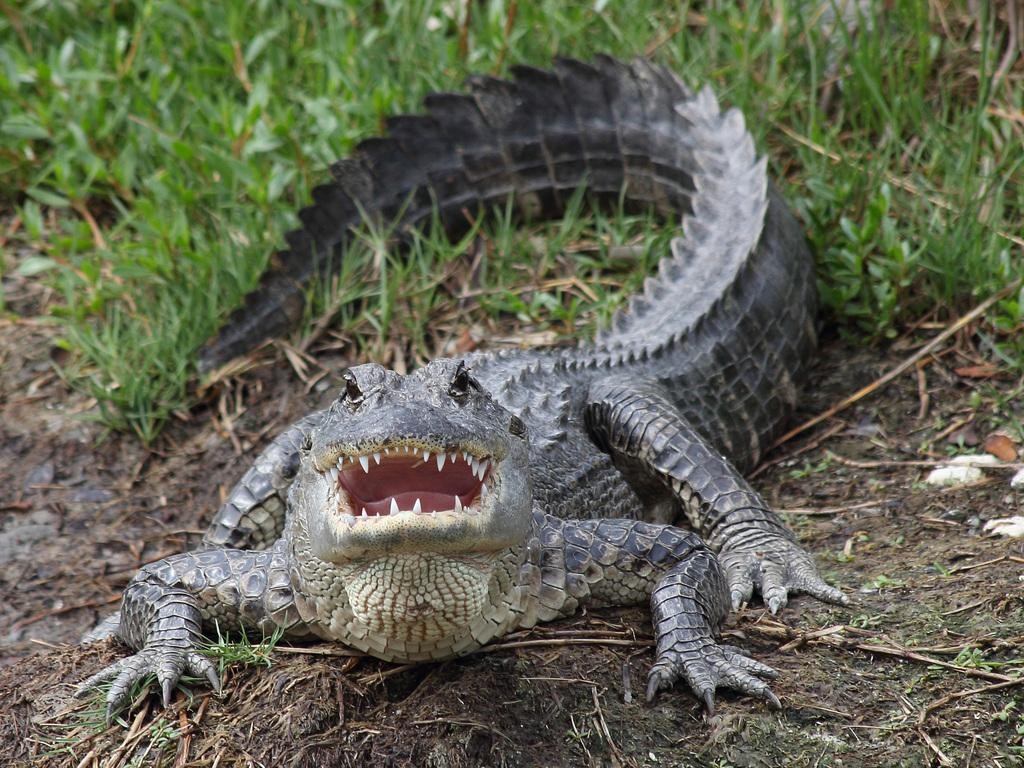What type of animal is in the image? There is a crocodile in the image. What type of terrain is visible in the image? Soil and grass are visible in the image. What type of party is being held in the image? There is no party present in the image; it features a crocodile, soil, and grass. What type of mineral is visible in the image? There is no mineral visible in the image; it features a crocodile, soil, and grass. 